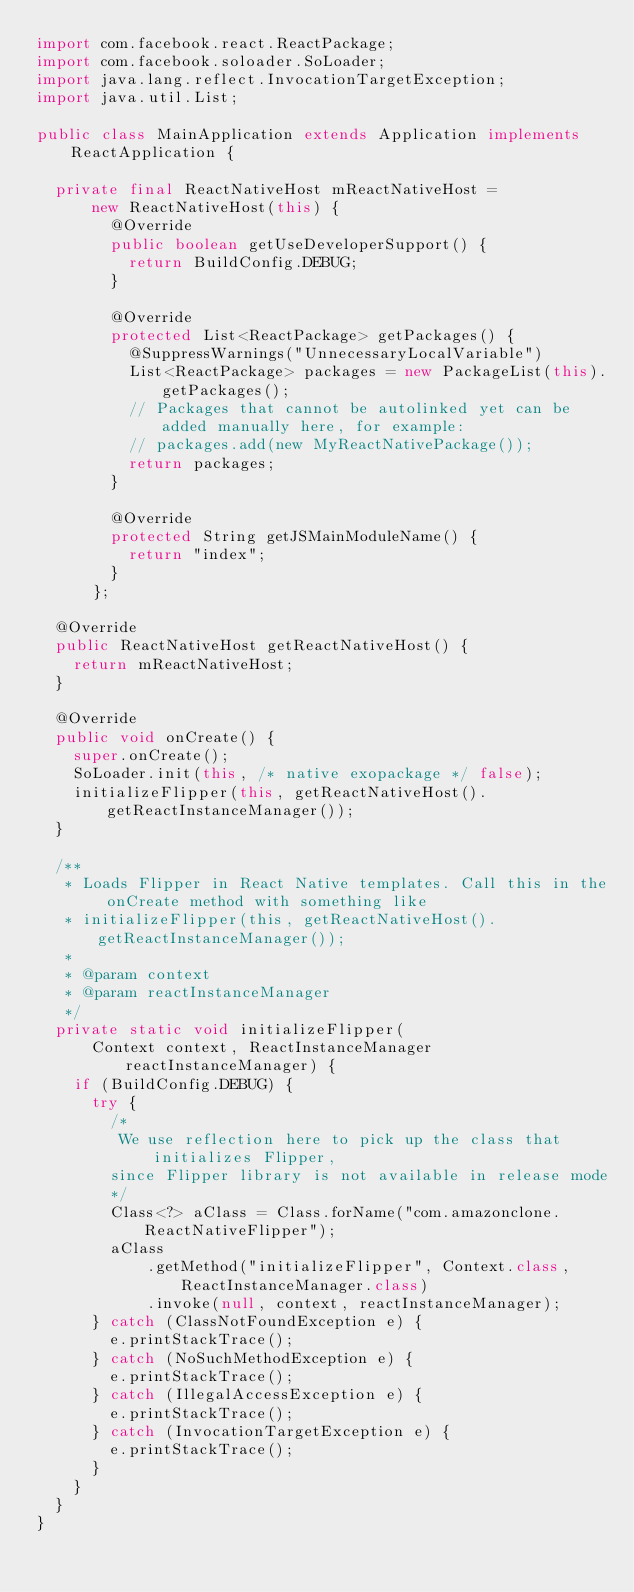Convert code to text. <code><loc_0><loc_0><loc_500><loc_500><_Java_>import com.facebook.react.ReactPackage;
import com.facebook.soloader.SoLoader;
import java.lang.reflect.InvocationTargetException;
import java.util.List;

public class MainApplication extends Application implements ReactApplication {

  private final ReactNativeHost mReactNativeHost =
      new ReactNativeHost(this) {
        @Override
        public boolean getUseDeveloperSupport() {
          return BuildConfig.DEBUG;
        }

        @Override
        protected List<ReactPackage> getPackages() {
          @SuppressWarnings("UnnecessaryLocalVariable")
          List<ReactPackage> packages = new PackageList(this).getPackages();
          // Packages that cannot be autolinked yet can be added manually here, for example:
          // packages.add(new MyReactNativePackage());
          return packages;
        }

        @Override
        protected String getJSMainModuleName() {
          return "index";
        }
      };

  @Override
  public ReactNativeHost getReactNativeHost() {
    return mReactNativeHost;
  }

  @Override
  public void onCreate() {
    super.onCreate();
    SoLoader.init(this, /* native exopackage */ false);
    initializeFlipper(this, getReactNativeHost().getReactInstanceManager());
  }

  /**
   * Loads Flipper in React Native templates. Call this in the onCreate method with something like
   * initializeFlipper(this, getReactNativeHost().getReactInstanceManager());
   *
   * @param context
   * @param reactInstanceManager
   */
  private static void initializeFlipper(
      Context context, ReactInstanceManager reactInstanceManager) {
    if (BuildConfig.DEBUG) {
      try {
        /*
         We use reflection here to pick up the class that initializes Flipper,
        since Flipper library is not available in release mode
        */
        Class<?> aClass = Class.forName("com.amazonclone.ReactNativeFlipper");
        aClass
            .getMethod("initializeFlipper", Context.class, ReactInstanceManager.class)
            .invoke(null, context, reactInstanceManager);
      } catch (ClassNotFoundException e) {
        e.printStackTrace();
      } catch (NoSuchMethodException e) {
        e.printStackTrace();
      } catch (IllegalAccessException e) {
        e.printStackTrace();
      } catch (InvocationTargetException e) {
        e.printStackTrace();
      }
    }
  }
}
</code> 